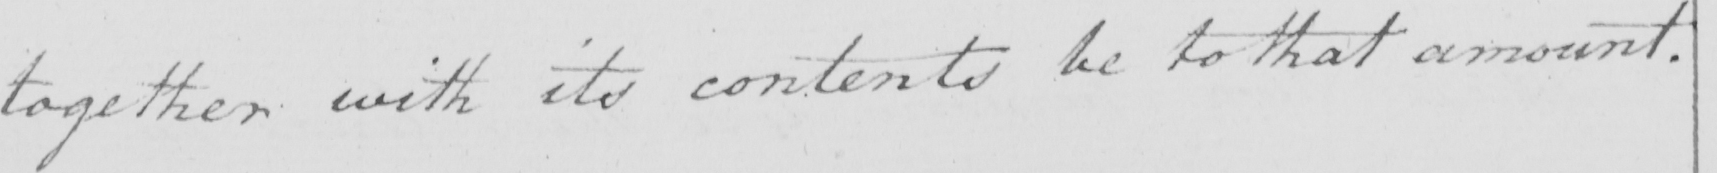Transcribe the text shown in this historical manuscript line. together with its contents be to that amount . 